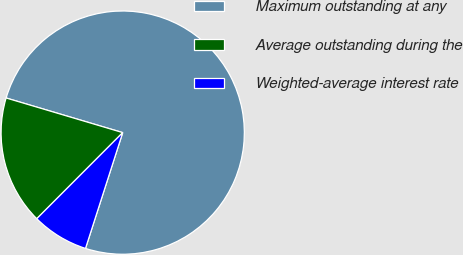<chart> <loc_0><loc_0><loc_500><loc_500><pie_chart><fcel>Maximum outstanding at any<fcel>Average outstanding during the<fcel>Weighted-average interest rate<nl><fcel>75.36%<fcel>17.11%<fcel>7.54%<nl></chart> 